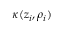<formula> <loc_0><loc_0><loc_500><loc_500>\kappa ( z _ { i } , \rho _ { i } )</formula> 